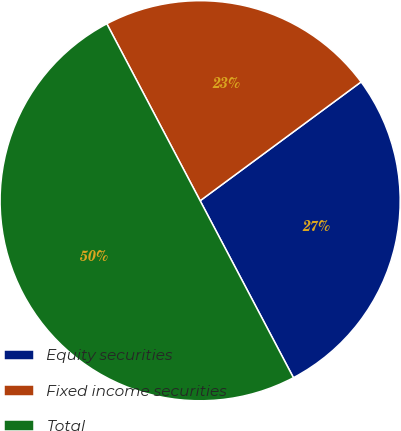Convert chart. <chart><loc_0><loc_0><loc_500><loc_500><pie_chart><fcel>Equity securities<fcel>Fixed income securities<fcel>Total<nl><fcel>27.4%<fcel>22.6%<fcel>50.0%<nl></chart> 